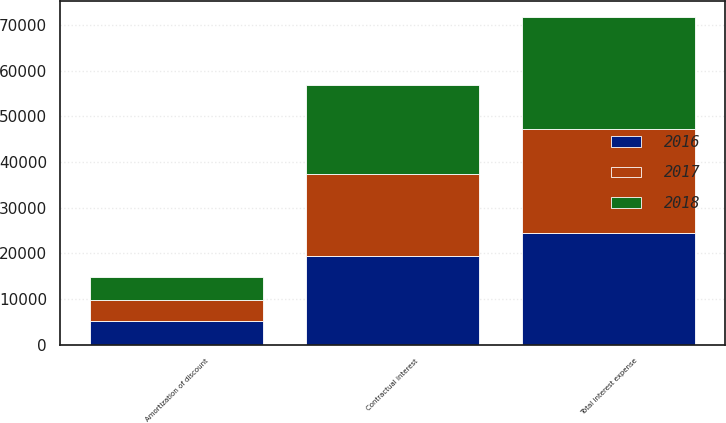Convert chart to OTSL. <chart><loc_0><loc_0><loc_500><loc_500><stacked_bar_chart><ecel><fcel>Contractual interest<fcel>Amortization of discount<fcel>Total interest expense<nl><fcel>2017<fcel>18106<fcel>4687<fcel>22793<nl><fcel>2016<fcel>19303<fcel>5103<fcel>24406<nl><fcel>2018<fcel>19483<fcel>4980<fcel>24463<nl></chart> 